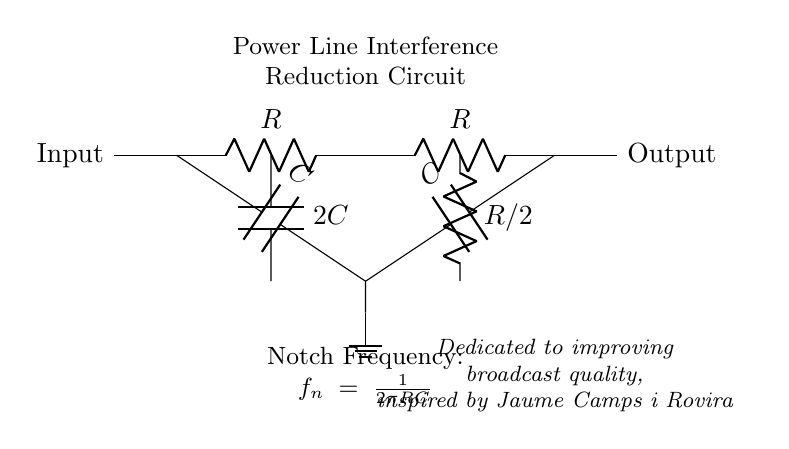What are the components in the circuit? The circuit contains resistors (R), capacitors (C), and a ground connection.
Answer: resistors and capacitors What is the value of the combined capacitance in the middle? The combined capacitance at the center is 2C, as indicated by the notation on the circuit.
Answer: 2C What is the resistance of the lower resistor? The lower resistor has a value of R/2, as it is labeled directly in the diagram.
Answer: R/2 What is the notch frequency formula? The notch frequency is given as f_n = 1 / (2πRC), which is written visibly in the circuit.
Answer: f_n = 1 / (2πRC) What is the purpose of this filter circuit? The purpose of the filter circuit is to reduce power line interference during audio broadcasts, as suggested in the notes.
Answer: Reduce power line interference What is the output of this circuit labeled as? The output is labeled simply as "Output" on the right side of the circuit diagram.
Answer: Output 